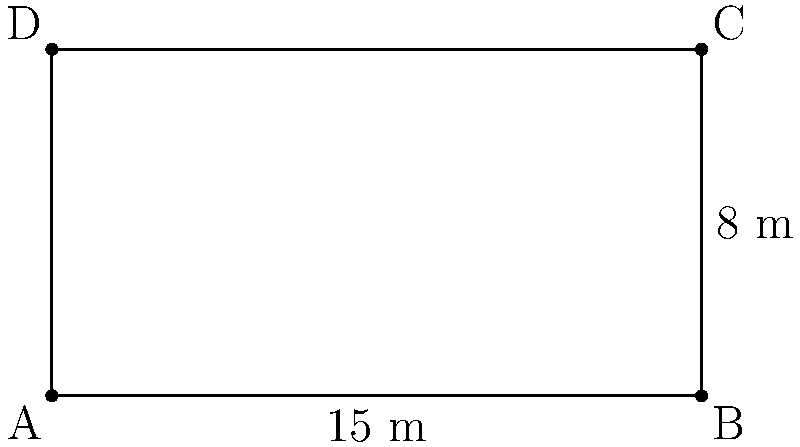You're setting up for a jazz performance on a rectangular stage. The stage measures 15 meters in length and 8 meters in width. To create a visually appealing border, you want to place LED light strips along the entire perimeter of the stage. How many meters of LED light strips will you need to purchase to cover the full perimeter of the stage? To find the perimeter of the rectangular stage, we need to add up the lengths of all four sides. Let's break it down step-by-step:

1. Identify the length and width of the stage:
   - Length = 15 meters
   - Width = 8 meters

2. The perimeter of a rectangle is given by the formula:
   $P = 2l + 2w$
   Where $P$ is the perimeter, $l$ is the length, and $w$ is the width.

3. Substitute the values into the formula:
   $P = 2(15) + 2(8)$

4. Simplify:
   $P = 30 + 16$

5. Calculate the final result:
   $P = 46$

Therefore, you will need 46 meters of LED light strips to cover the entire perimeter of the stage.
Answer: 46 meters 